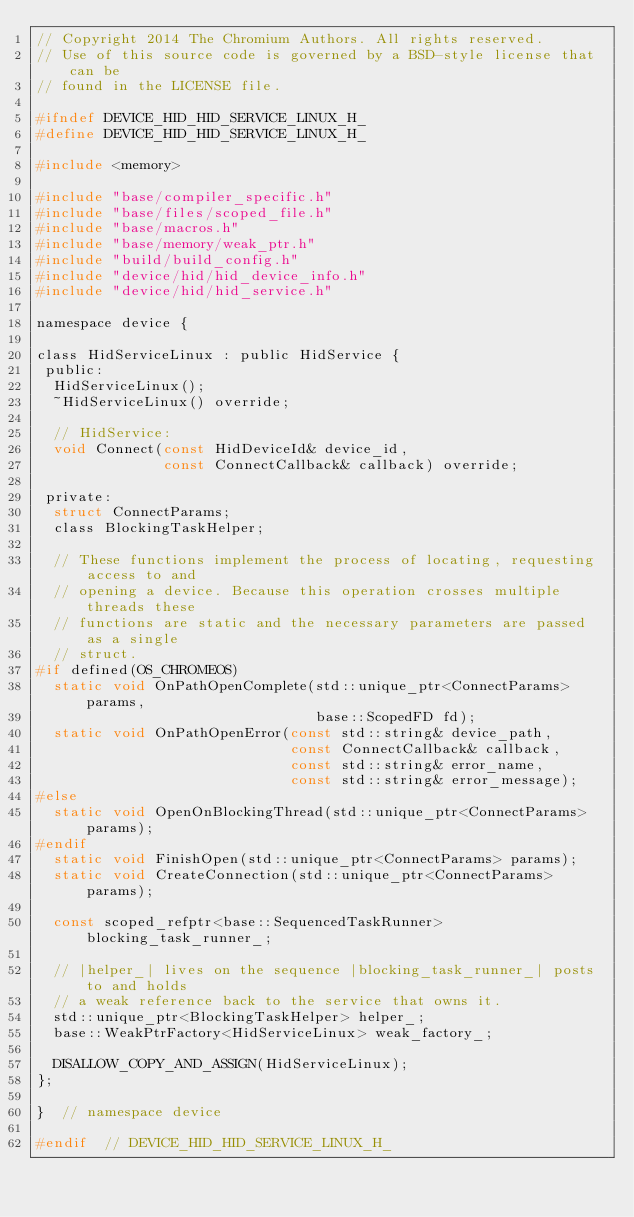Convert code to text. <code><loc_0><loc_0><loc_500><loc_500><_C_>// Copyright 2014 The Chromium Authors. All rights reserved.
// Use of this source code is governed by a BSD-style license that can be
// found in the LICENSE file.

#ifndef DEVICE_HID_HID_SERVICE_LINUX_H_
#define DEVICE_HID_HID_SERVICE_LINUX_H_

#include <memory>

#include "base/compiler_specific.h"
#include "base/files/scoped_file.h"
#include "base/macros.h"
#include "base/memory/weak_ptr.h"
#include "build/build_config.h"
#include "device/hid/hid_device_info.h"
#include "device/hid/hid_service.h"

namespace device {

class HidServiceLinux : public HidService {
 public:
  HidServiceLinux();
  ~HidServiceLinux() override;

  // HidService:
  void Connect(const HidDeviceId& device_id,
               const ConnectCallback& callback) override;

 private:
  struct ConnectParams;
  class BlockingTaskHelper;

  // These functions implement the process of locating, requesting access to and
  // opening a device. Because this operation crosses multiple threads these
  // functions are static and the necessary parameters are passed as a single
  // struct.
#if defined(OS_CHROMEOS)
  static void OnPathOpenComplete(std::unique_ptr<ConnectParams> params,
                                 base::ScopedFD fd);
  static void OnPathOpenError(const std::string& device_path,
                              const ConnectCallback& callback,
                              const std::string& error_name,
                              const std::string& error_message);
#else
  static void OpenOnBlockingThread(std::unique_ptr<ConnectParams> params);
#endif
  static void FinishOpen(std::unique_ptr<ConnectParams> params);
  static void CreateConnection(std::unique_ptr<ConnectParams> params);

  const scoped_refptr<base::SequencedTaskRunner> blocking_task_runner_;

  // |helper_| lives on the sequence |blocking_task_runner_| posts to and holds
  // a weak reference back to the service that owns it.
  std::unique_ptr<BlockingTaskHelper> helper_;
  base::WeakPtrFactory<HidServiceLinux> weak_factory_;

  DISALLOW_COPY_AND_ASSIGN(HidServiceLinux);
};

}  // namespace device

#endif  // DEVICE_HID_HID_SERVICE_LINUX_H_
</code> 